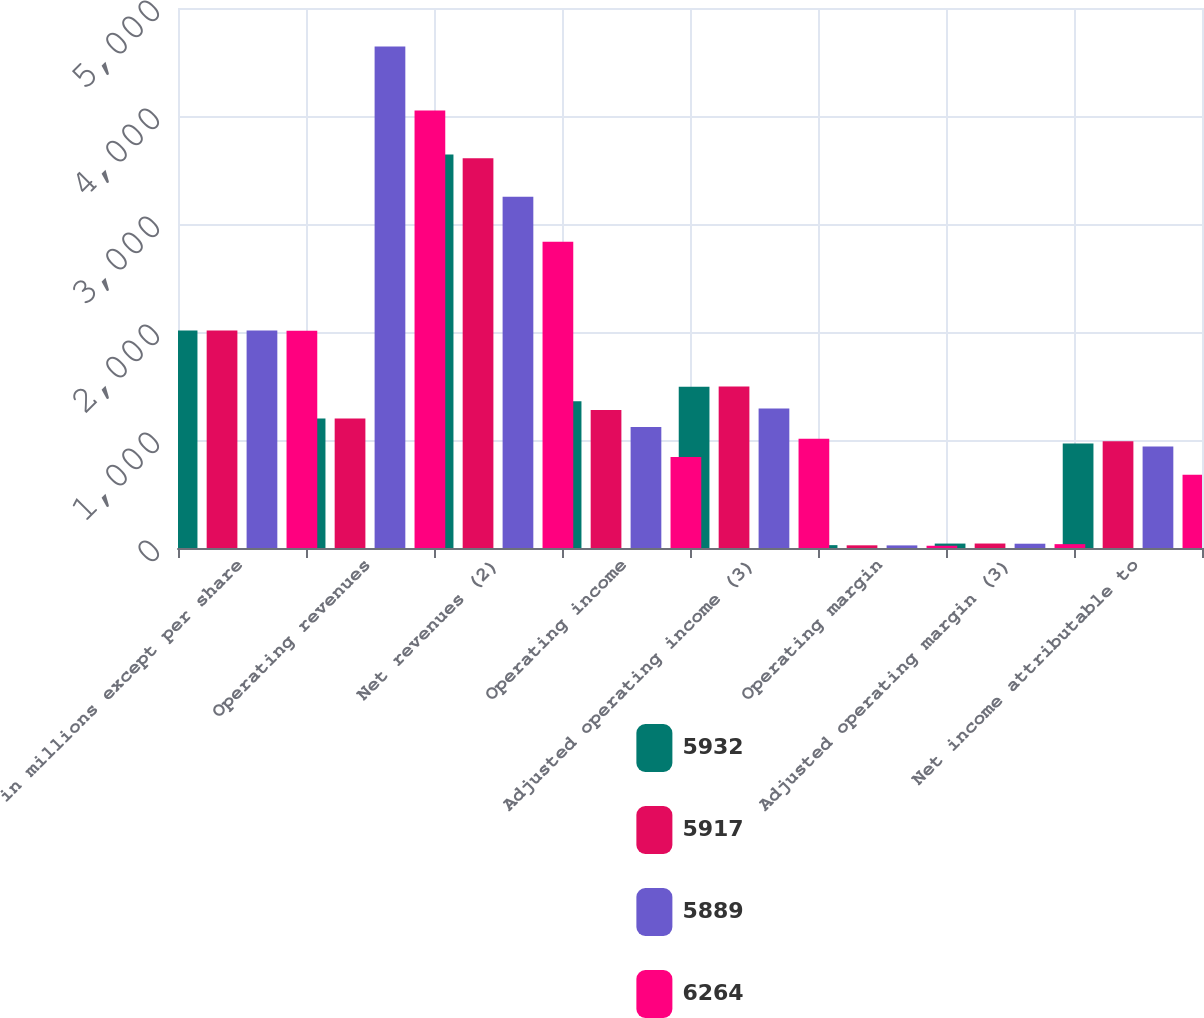Convert chart to OTSL. <chart><loc_0><loc_0><loc_500><loc_500><stacked_bar_chart><ecel><fcel>in millions except per share<fcel>Operating revenues<fcel>Net revenues (2)<fcel>Operating income<fcel>Adjusted operating income (3)<fcel>Operating margin<fcel>Adjusted operating margin (3)<fcel>Net income attributable to<nl><fcel>5932<fcel>2015<fcel>1198.55<fcel>3643.2<fcel>1358.4<fcel>1493.7<fcel>26.5<fcel>41<fcel>968.1<nl><fcel>5917<fcel>2014<fcel>1198.55<fcel>3608.3<fcel>1276.9<fcel>1495<fcel>24.8<fcel>41.4<fcel>988.1<nl><fcel>5889<fcel>2013<fcel>4644.6<fcel>3252<fcel>1120.2<fcel>1292.1<fcel>24.1<fcel>39.7<fcel>940.3<nl><fcel>6264<fcel>2012<fcel>4050.4<fcel>2836<fcel>842.6<fcel>1012.1<fcel>20.8<fcel>35.7<fcel>677.1<nl></chart> 